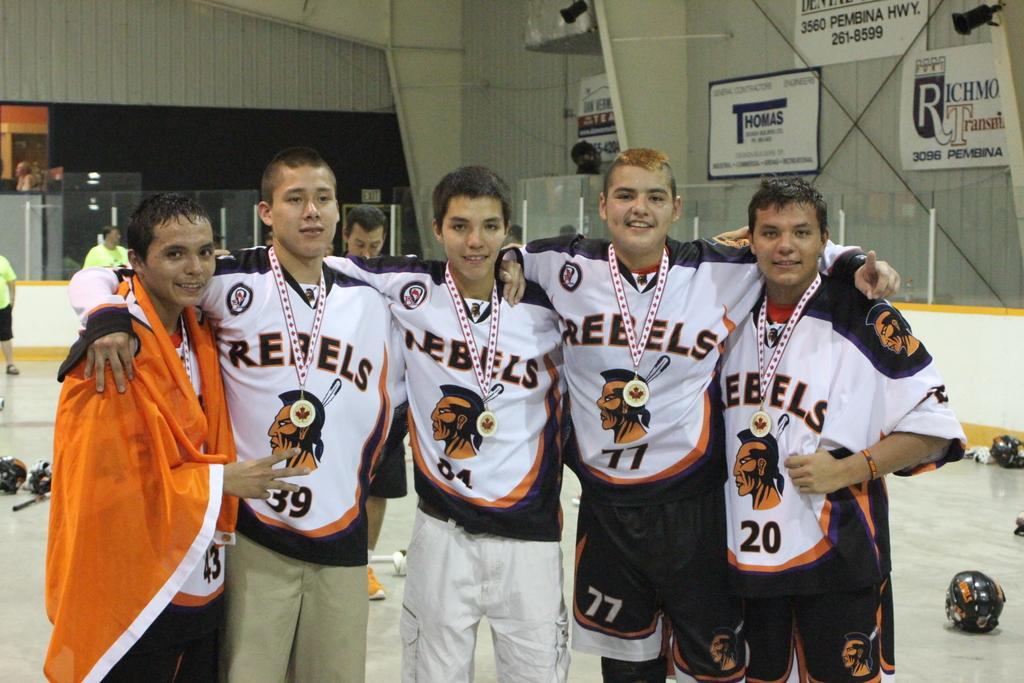<image>
Share a concise interpretation of the image provided. Several members of the Rebels stand wearing medals. 